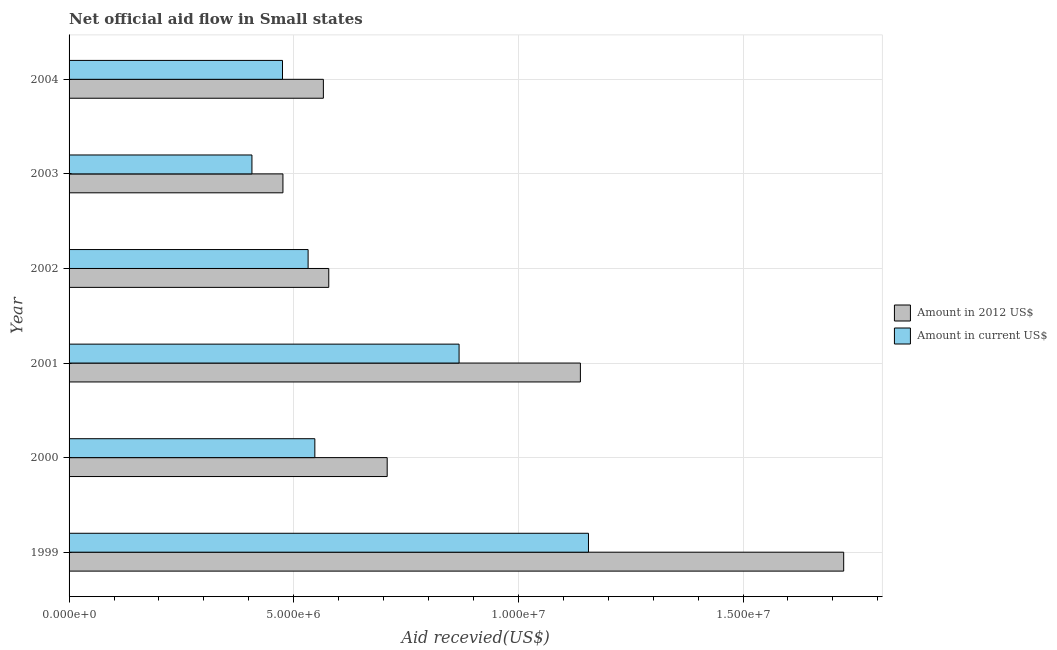How many groups of bars are there?
Offer a very short reply. 6. What is the amount of aid received(expressed in us$) in 2000?
Give a very brief answer. 5.47e+06. Across all years, what is the maximum amount of aid received(expressed in 2012 us$)?
Offer a very short reply. 1.72e+07. Across all years, what is the minimum amount of aid received(expressed in 2012 us$)?
Provide a succinct answer. 4.76e+06. What is the total amount of aid received(expressed in us$) in the graph?
Provide a succinct answer. 3.98e+07. What is the difference between the amount of aid received(expressed in 2012 us$) in 1999 and that in 2003?
Your answer should be very brief. 1.25e+07. What is the difference between the amount of aid received(expressed in us$) in 2004 and the amount of aid received(expressed in 2012 us$) in 2001?
Your answer should be very brief. -6.63e+06. What is the average amount of aid received(expressed in 2012 us$) per year?
Provide a succinct answer. 8.65e+06. In the year 2000, what is the difference between the amount of aid received(expressed in us$) and amount of aid received(expressed in 2012 us$)?
Provide a short and direct response. -1.61e+06. In how many years, is the amount of aid received(expressed in 2012 us$) greater than 10000000 US$?
Ensure brevity in your answer.  2. What is the ratio of the amount of aid received(expressed in 2012 us$) in 1999 to that in 2003?
Keep it short and to the point. 3.62. Is the amount of aid received(expressed in us$) in 2003 less than that in 2004?
Make the answer very short. Yes. Is the difference between the amount of aid received(expressed in 2012 us$) in 2002 and 2004 greater than the difference between the amount of aid received(expressed in us$) in 2002 and 2004?
Your response must be concise. No. What is the difference between the highest and the second highest amount of aid received(expressed in us$)?
Offer a terse response. 2.88e+06. What is the difference between the highest and the lowest amount of aid received(expressed in 2012 us$)?
Offer a terse response. 1.25e+07. What does the 2nd bar from the top in 2001 represents?
Your response must be concise. Amount in 2012 US$. What does the 2nd bar from the bottom in 2001 represents?
Make the answer very short. Amount in current US$. Does the graph contain any zero values?
Offer a terse response. No. What is the title of the graph?
Make the answer very short. Net official aid flow in Small states. What is the label or title of the X-axis?
Your answer should be compact. Aid recevied(US$). What is the Aid recevied(US$) in Amount in 2012 US$ in 1999?
Ensure brevity in your answer.  1.72e+07. What is the Aid recevied(US$) in Amount in current US$ in 1999?
Make the answer very short. 1.16e+07. What is the Aid recevied(US$) of Amount in 2012 US$ in 2000?
Ensure brevity in your answer.  7.08e+06. What is the Aid recevied(US$) in Amount in current US$ in 2000?
Give a very brief answer. 5.47e+06. What is the Aid recevied(US$) of Amount in 2012 US$ in 2001?
Provide a short and direct response. 1.14e+07. What is the Aid recevied(US$) of Amount in current US$ in 2001?
Your answer should be compact. 8.68e+06. What is the Aid recevied(US$) in Amount in 2012 US$ in 2002?
Provide a succinct answer. 5.78e+06. What is the Aid recevied(US$) of Amount in current US$ in 2002?
Offer a terse response. 5.32e+06. What is the Aid recevied(US$) in Amount in 2012 US$ in 2003?
Offer a terse response. 4.76e+06. What is the Aid recevied(US$) in Amount in current US$ in 2003?
Provide a succinct answer. 4.07e+06. What is the Aid recevied(US$) in Amount in 2012 US$ in 2004?
Your answer should be compact. 5.66e+06. What is the Aid recevied(US$) of Amount in current US$ in 2004?
Provide a succinct answer. 4.75e+06. Across all years, what is the maximum Aid recevied(US$) in Amount in 2012 US$?
Keep it short and to the point. 1.72e+07. Across all years, what is the maximum Aid recevied(US$) in Amount in current US$?
Ensure brevity in your answer.  1.16e+07. Across all years, what is the minimum Aid recevied(US$) of Amount in 2012 US$?
Keep it short and to the point. 4.76e+06. Across all years, what is the minimum Aid recevied(US$) in Amount in current US$?
Give a very brief answer. 4.07e+06. What is the total Aid recevied(US$) in Amount in 2012 US$ in the graph?
Make the answer very short. 5.19e+07. What is the total Aid recevied(US$) of Amount in current US$ in the graph?
Your response must be concise. 3.98e+07. What is the difference between the Aid recevied(US$) in Amount in 2012 US$ in 1999 and that in 2000?
Provide a succinct answer. 1.02e+07. What is the difference between the Aid recevied(US$) of Amount in current US$ in 1999 and that in 2000?
Offer a very short reply. 6.09e+06. What is the difference between the Aid recevied(US$) of Amount in 2012 US$ in 1999 and that in 2001?
Your answer should be very brief. 5.86e+06. What is the difference between the Aid recevied(US$) in Amount in current US$ in 1999 and that in 2001?
Ensure brevity in your answer.  2.88e+06. What is the difference between the Aid recevied(US$) of Amount in 2012 US$ in 1999 and that in 2002?
Make the answer very short. 1.15e+07. What is the difference between the Aid recevied(US$) of Amount in current US$ in 1999 and that in 2002?
Your response must be concise. 6.24e+06. What is the difference between the Aid recevied(US$) of Amount in 2012 US$ in 1999 and that in 2003?
Provide a short and direct response. 1.25e+07. What is the difference between the Aid recevied(US$) in Amount in current US$ in 1999 and that in 2003?
Ensure brevity in your answer.  7.49e+06. What is the difference between the Aid recevied(US$) in Amount in 2012 US$ in 1999 and that in 2004?
Give a very brief answer. 1.16e+07. What is the difference between the Aid recevied(US$) in Amount in current US$ in 1999 and that in 2004?
Offer a terse response. 6.81e+06. What is the difference between the Aid recevied(US$) in Amount in 2012 US$ in 2000 and that in 2001?
Your answer should be compact. -4.30e+06. What is the difference between the Aid recevied(US$) of Amount in current US$ in 2000 and that in 2001?
Offer a very short reply. -3.21e+06. What is the difference between the Aid recevied(US$) in Amount in 2012 US$ in 2000 and that in 2002?
Make the answer very short. 1.30e+06. What is the difference between the Aid recevied(US$) of Amount in current US$ in 2000 and that in 2002?
Ensure brevity in your answer.  1.50e+05. What is the difference between the Aid recevied(US$) of Amount in 2012 US$ in 2000 and that in 2003?
Give a very brief answer. 2.32e+06. What is the difference between the Aid recevied(US$) in Amount in current US$ in 2000 and that in 2003?
Make the answer very short. 1.40e+06. What is the difference between the Aid recevied(US$) of Amount in 2012 US$ in 2000 and that in 2004?
Your response must be concise. 1.42e+06. What is the difference between the Aid recevied(US$) of Amount in current US$ in 2000 and that in 2004?
Keep it short and to the point. 7.20e+05. What is the difference between the Aid recevied(US$) in Amount in 2012 US$ in 2001 and that in 2002?
Provide a succinct answer. 5.60e+06. What is the difference between the Aid recevied(US$) in Amount in current US$ in 2001 and that in 2002?
Give a very brief answer. 3.36e+06. What is the difference between the Aid recevied(US$) in Amount in 2012 US$ in 2001 and that in 2003?
Keep it short and to the point. 6.62e+06. What is the difference between the Aid recevied(US$) in Amount in current US$ in 2001 and that in 2003?
Your answer should be compact. 4.61e+06. What is the difference between the Aid recevied(US$) in Amount in 2012 US$ in 2001 and that in 2004?
Your answer should be very brief. 5.72e+06. What is the difference between the Aid recevied(US$) of Amount in current US$ in 2001 and that in 2004?
Make the answer very short. 3.93e+06. What is the difference between the Aid recevied(US$) in Amount in 2012 US$ in 2002 and that in 2003?
Keep it short and to the point. 1.02e+06. What is the difference between the Aid recevied(US$) in Amount in current US$ in 2002 and that in 2003?
Keep it short and to the point. 1.25e+06. What is the difference between the Aid recevied(US$) of Amount in 2012 US$ in 2002 and that in 2004?
Your answer should be very brief. 1.20e+05. What is the difference between the Aid recevied(US$) of Amount in current US$ in 2002 and that in 2004?
Keep it short and to the point. 5.70e+05. What is the difference between the Aid recevied(US$) in Amount in 2012 US$ in 2003 and that in 2004?
Your answer should be very brief. -9.00e+05. What is the difference between the Aid recevied(US$) of Amount in current US$ in 2003 and that in 2004?
Ensure brevity in your answer.  -6.80e+05. What is the difference between the Aid recevied(US$) in Amount in 2012 US$ in 1999 and the Aid recevied(US$) in Amount in current US$ in 2000?
Your answer should be compact. 1.18e+07. What is the difference between the Aid recevied(US$) in Amount in 2012 US$ in 1999 and the Aid recevied(US$) in Amount in current US$ in 2001?
Your answer should be very brief. 8.56e+06. What is the difference between the Aid recevied(US$) in Amount in 2012 US$ in 1999 and the Aid recevied(US$) in Amount in current US$ in 2002?
Your answer should be very brief. 1.19e+07. What is the difference between the Aid recevied(US$) in Amount in 2012 US$ in 1999 and the Aid recevied(US$) in Amount in current US$ in 2003?
Keep it short and to the point. 1.32e+07. What is the difference between the Aid recevied(US$) in Amount in 2012 US$ in 1999 and the Aid recevied(US$) in Amount in current US$ in 2004?
Keep it short and to the point. 1.25e+07. What is the difference between the Aid recevied(US$) in Amount in 2012 US$ in 2000 and the Aid recevied(US$) in Amount in current US$ in 2001?
Ensure brevity in your answer.  -1.60e+06. What is the difference between the Aid recevied(US$) of Amount in 2012 US$ in 2000 and the Aid recevied(US$) of Amount in current US$ in 2002?
Your answer should be very brief. 1.76e+06. What is the difference between the Aid recevied(US$) in Amount in 2012 US$ in 2000 and the Aid recevied(US$) in Amount in current US$ in 2003?
Provide a succinct answer. 3.01e+06. What is the difference between the Aid recevied(US$) of Amount in 2012 US$ in 2000 and the Aid recevied(US$) of Amount in current US$ in 2004?
Your response must be concise. 2.33e+06. What is the difference between the Aid recevied(US$) in Amount in 2012 US$ in 2001 and the Aid recevied(US$) in Amount in current US$ in 2002?
Make the answer very short. 6.06e+06. What is the difference between the Aid recevied(US$) in Amount in 2012 US$ in 2001 and the Aid recevied(US$) in Amount in current US$ in 2003?
Give a very brief answer. 7.31e+06. What is the difference between the Aid recevied(US$) of Amount in 2012 US$ in 2001 and the Aid recevied(US$) of Amount in current US$ in 2004?
Your response must be concise. 6.63e+06. What is the difference between the Aid recevied(US$) in Amount in 2012 US$ in 2002 and the Aid recevied(US$) in Amount in current US$ in 2003?
Offer a terse response. 1.71e+06. What is the difference between the Aid recevied(US$) of Amount in 2012 US$ in 2002 and the Aid recevied(US$) of Amount in current US$ in 2004?
Offer a terse response. 1.03e+06. What is the difference between the Aid recevied(US$) of Amount in 2012 US$ in 2003 and the Aid recevied(US$) of Amount in current US$ in 2004?
Give a very brief answer. 10000. What is the average Aid recevied(US$) of Amount in 2012 US$ per year?
Your answer should be compact. 8.65e+06. What is the average Aid recevied(US$) in Amount in current US$ per year?
Keep it short and to the point. 6.64e+06. In the year 1999, what is the difference between the Aid recevied(US$) in Amount in 2012 US$ and Aid recevied(US$) in Amount in current US$?
Ensure brevity in your answer.  5.68e+06. In the year 2000, what is the difference between the Aid recevied(US$) of Amount in 2012 US$ and Aid recevied(US$) of Amount in current US$?
Make the answer very short. 1.61e+06. In the year 2001, what is the difference between the Aid recevied(US$) of Amount in 2012 US$ and Aid recevied(US$) of Amount in current US$?
Keep it short and to the point. 2.70e+06. In the year 2003, what is the difference between the Aid recevied(US$) of Amount in 2012 US$ and Aid recevied(US$) of Amount in current US$?
Your response must be concise. 6.90e+05. In the year 2004, what is the difference between the Aid recevied(US$) of Amount in 2012 US$ and Aid recevied(US$) of Amount in current US$?
Ensure brevity in your answer.  9.10e+05. What is the ratio of the Aid recevied(US$) in Amount in 2012 US$ in 1999 to that in 2000?
Offer a very short reply. 2.44. What is the ratio of the Aid recevied(US$) of Amount in current US$ in 1999 to that in 2000?
Provide a succinct answer. 2.11. What is the ratio of the Aid recevied(US$) in Amount in 2012 US$ in 1999 to that in 2001?
Provide a short and direct response. 1.51. What is the ratio of the Aid recevied(US$) in Amount in current US$ in 1999 to that in 2001?
Give a very brief answer. 1.33. What is the ratio of the Aid recevied(US$) of Amount in 2012 US$ in 1999 to that in 2002?
Provide a succinct answer. 2.98. What is the ratio of the Aid recevied(US$) of Amount in current US$ in 1999 to that in 2002?
Keep it short and to the point. 2.17. What is the ratio of the Aid recevied(US$) of Amount in 2012 US$ in 1999 to that in 2003?
Provide a succinct answer. 3.62. What is the ratio of the Aid recevied(US$) in Amount in current US$ in 1999 to that in 2003?
Offer a terse response. 2.84. What is the ratio of the Aid recevied(US$) of Amount in 2012 US$ in 1999 to that in 2004?
Give a very brief answer. 3.05. What is the ratio of the Aid recevied(US$) of Amount in current US$ in 1999 to that in 2004?
Give a very brief answer. 2.43. What is the ratio of the Aid recevied(US$) of Amount in 2012 US$ in 2000 to that in 2001?
Your answer should be compact. 0.62. What is the ratio of the Aid recevied(US$) of Amount in current US$ in 2000 to that in 2001?
Offer a very short reply. 0.63. What is the ratio of the Aid recevied(US$) of Amount in 2012 US$ in 2000 to that in 2002?
Your response must be concise. 1.22. What is the ratio of the Aid recevied(US$) in Amount in current US$ in 2000 to that in 2002?
Your response must be concise. 1.03. What is the ratio of the Aid recevied(US$) of Amount in 2012 US$ in 2000 to that in 2003?
Provide a succinct answer. 1.49. What is the ratio of the Aid recevied(US$) of Amount in current US$ in 2000 to that in 2003?
Provide a short and direct response. 1.34. What is the ratio of the Aid recevied(US$) in Amount in 2012 US$ in 2000 to that in 2004?
Your answer should be compact. 1.25. What is the ratio of the Aid recevied(US$) of Amount in current US$ in 2000 to that in 2004?
Provide a succinct answer. 1.15. What is the ratio of the Aid recevied(US$) of Amount in 2012 US$ in 2001 to that in 2002?
Provide a short and direct response. 1.97. What is the ratio of the Aid recevied(US$) in Amount in current US$ in 2001 to that in 2002?
Provide a short and direct response. 1.63. What is the ratio of the Aid recevied(US$) in Amount in 2012 US$ in 2001 to that in 2003?
Your response must be concise. 2.39. What is the ratio of the Aid recevied(US$) in Amount in current US$ in 2001 to that in 2003?
Your answer should be compact. 2.13. What is the ratio of the Aid recevied(US$) in Amount in 2012 US$ in 2001 to that in 2004?
Provide a short and direct response. 2.01. What is the ratio of the Aid recevied(US$) in Amount in current US$ in 2001 to that in 2004?
Make the answer very short. 1.83. What is the ratio of the Aid recevied(US$) in Amount in 2012 US$ in 2002 to that in 2003?
Ensure brevity in your answer.  1.21. What is the ratio of the Aid recevied(US$) of Amount in current US$ in 2002 to that in 2003?
Keep it short and to the point. 1.31. What is the ratio of the Aid recevied(US$) in Amount in 2012 US$ in 2002 to that in 2004?
Provide a short and direct response. 1.02. What is the ratio of the Aid recevied(US$) of Amount in current US$ in 2002 to that in 2004?
Keep it short and to the point. 1.12. What is the ratio of the Aid recevied(US$) of Amount in 2012 US$ in 2003 to that in 2004?
Offer a very short reply. 0.84. What is the ratio of the Aid recevied(US$) of Amount in current US$ in 2003 to that in 2004?
Offer a very short reply. 0.86. What is the difference between the highest and the second highest Aid recevied(US$) of Amount in 2012 US$?
Offer a very short reply. 5.86e+06. What is the difference between the highest and the second highest Aid recevied(US$) of Amount in current US$?
Provide a short and direct response. 2.88e+06. What is the difference between the highest and the lowest Aid recevied(US$) in Amount in 2012 US$?
Ensure brevity in your answer.  1.25e+07. What is the difference between the highest and the lowest Aid recevied(US$) in Amount in current US$?
Your response must be concise. 7.49e+06. 